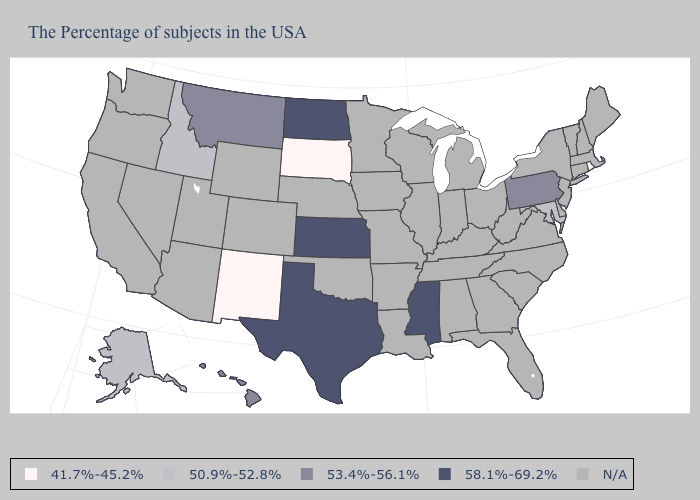What is the lowest value in the MidWest?
Give a very brief answer. 41.7%-45.2%. Is the legend a continuous bar?
Concise answer only. No. What is the value of Indiana?
Quick response, please. N/A. What is the value of Utah?
Answer briefly. N/A. Does Alaska have the lowest value in the USA?
Answer briefly. No. How many symbols are there in the legend?
Answer briefly. 5. Does the first symbol in the legend represent the smallest category?
Write a very short answer. Yes. What is the value of South Dakota?
Give a very brief answer. 41.7%-45.2%. Name the states that have a value in the range N/A?
Give a very brief answer. Maine, Massachusetts, New Hampshire, Vermont, Connecticut, New York, New Jersey, Delaware, Virginia, North Carolina, South Carolina, West Virginia, Ohio, Florida, Georgia, Michigan, Kentucky, Indiana, Alabama, Tennessee, Wisconsin, Illinois, Louisiana, Missouri, Arkansas, Minnesota, Iowa, Nebraska, Oklahoma, Wyoming, Colorado, Utah, Arizona, Nevada, California, Washington, Oregon. What is the value of North Dakota?
Keep it brief. 58.1%-69.2%. Name the states that have a value in the range 53.4%-56.1%?
Give a very brief answer. Pennsylvania, Montana, Hawaii. 